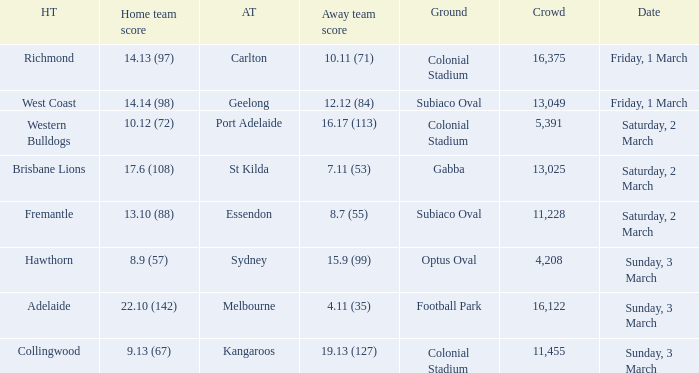Who is the away team when the home team scored 17.6 (108)? St Kilda. 